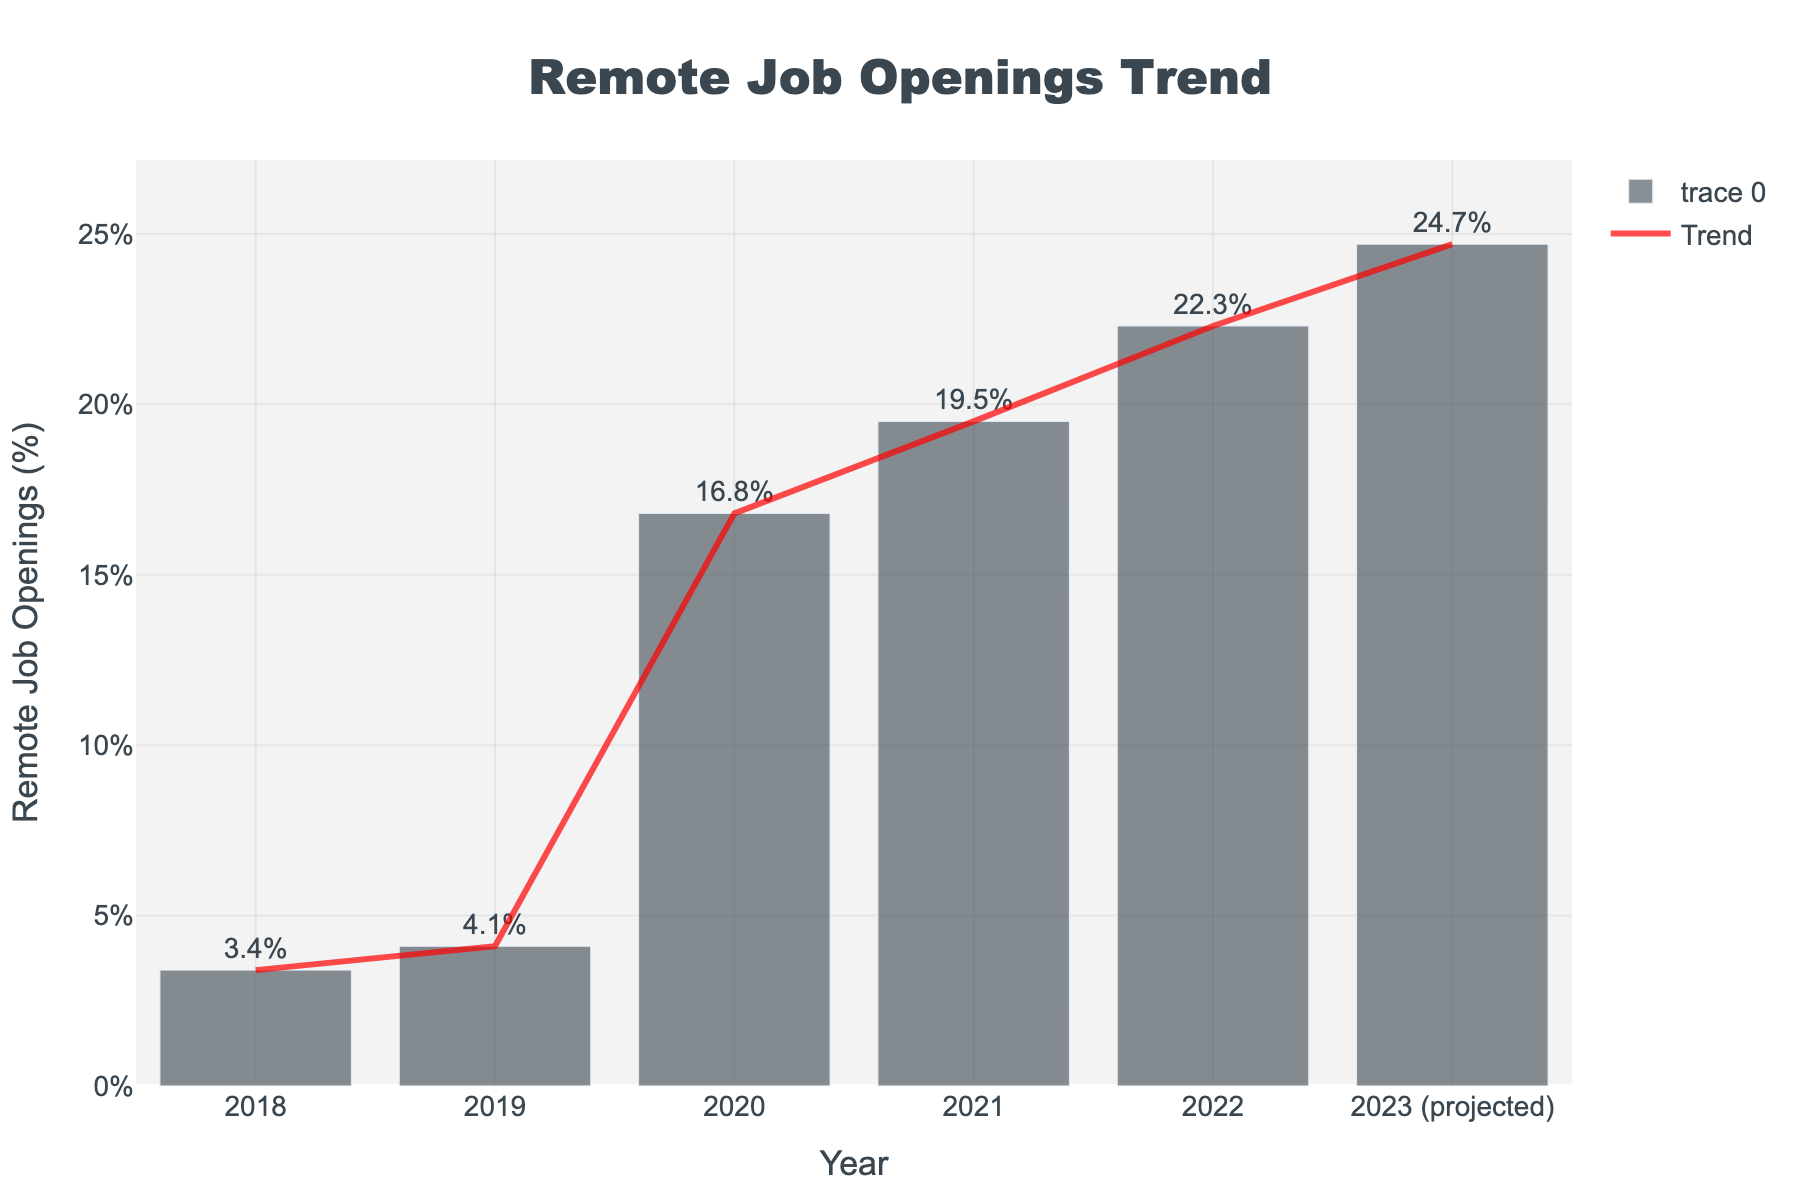What's the percentage increase in remote job openings from 2018 to 2020? Subtract the 2018 percentage (3.4%) from the 2020 percentage (16.8%), then divide the result by the 2018 percentage and multiply by 100. Calculation: ((16.8 - 3.4) / 3.4) * 100
Answer: 394.1% In which year was the highest increase in remote job openings observed between consecutive years? By looking at the visual lengths of the bars and their differences, the largest increase is from 2019 (4.1%) to 2020 (16.8%). Subtract the percentages to find the year with the highest increase: 16.8 - 4.1 = 12.7%
Answer: 2020 What is the average percentage of remote job openings from 2019 to 2021? Sum the percentages of the years 2019, 2020, and 2021 (4.1% + 16.8% + 19.5%) and then divide by 3 for the average. Calculation: (4.1 + 16.8 + 19.5) / 3
Answer: 13.47% Compare the projected percentage in 2023 to the percentage in 2022. What is the difference? Subtract the 2022 percentage (22.3%) from the projected percentage in 2023 (24.7%). Calculation: 24.7 - 22.3
Answer: 2.4% Which year exhibited the smallest percentage of remote job openings? By observing the lengths of the bars in the figure, the shortest bar corresponds to 2018, which is 3.4%.
Answer: 2018 How many years showed an increase of more than 3% in remote job openings from the previous year? Examine each year and count the years with an increase greater than 3%. Increases: 2019-2018 = 0.7%, 2020-2019 = 12.7%, 2021-2020 = 2.7%, 2022-2021 = 2.8%, 2023-2022 = 2.4%. Only 2020 showed an increase greater than 3%.
Answer: 1 year What is the overall trend of remote job openings from 2018 to 2023 as depicted by the line in the figure? The line illustrates a steady increase in remote job openings every year from 2018 to the projected 2023 percentage, demonstrating a clear upward trend.
Answer: Upward trend Which two consecutive years showed the smallest increase in the percentage of remote job openings? Compare annual increases: 2019-2018 = 0.7%, 2020-2019 = 12.7%, 2021-2020 = 2.7%, 2022-2021 = 2.8%, 2023-2022 = 2.4%. The smallest increase is between 2018 and 2019.
Answer: 2018 to 2019 